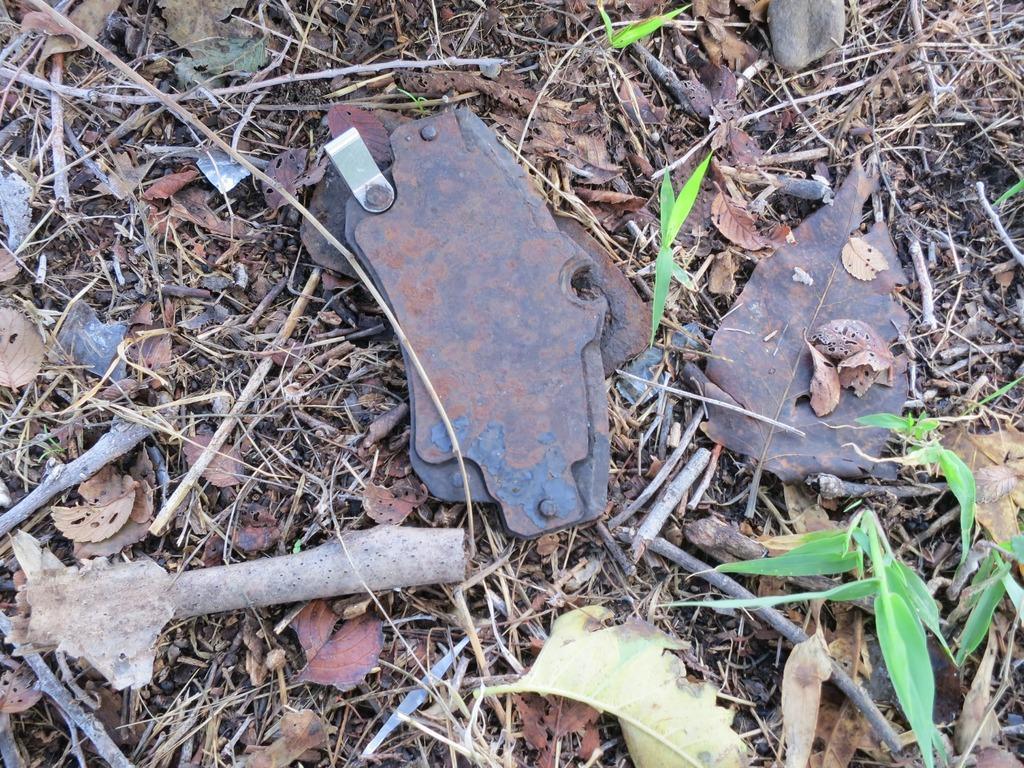In one or two sentences, can you explain what this image depicts? In the image we can see the leaves, dry leaves and small wooden sticks. Here we can see a metal object. 